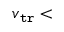<formula> <loc_0><loc_0><loc_500><loc_500>v _ { \tt t r } <</formula> 